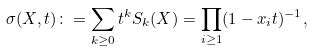Convert formula to latex. <formula><loc_0><loc_0><loc_500><loc_500>\sigma ( X , t ) \colon = \sum _ { k \geq 0 } t ^ { k } S _ { k } ( X ) = \prod _ { i \geq 1 } ( 1 - x _ { i } t ) ^ { - 1 } ,</formula> 